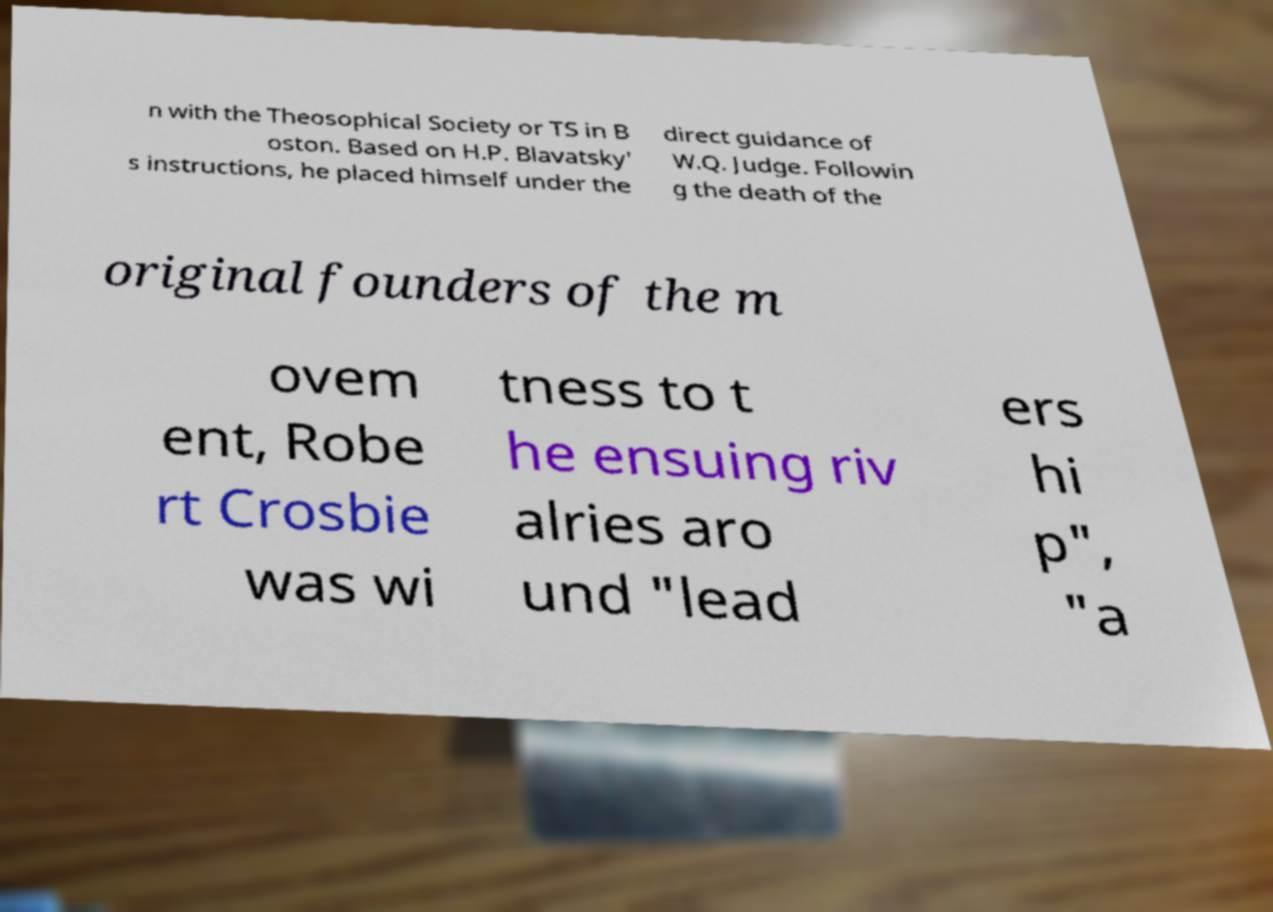Can you accurately transcribe the text from the provided image for me? n with the Theosophical Society or TS in B oston. Based on H.P. Blavatsky' s instructions, he placed himself under the direct guidance of W.Q. Judge. Followin g the death of the original founders of the m ovem ent, Robe rt Crosbie was wi tness to t he ensuing riv alries aro und "lead ers hi p", "a 